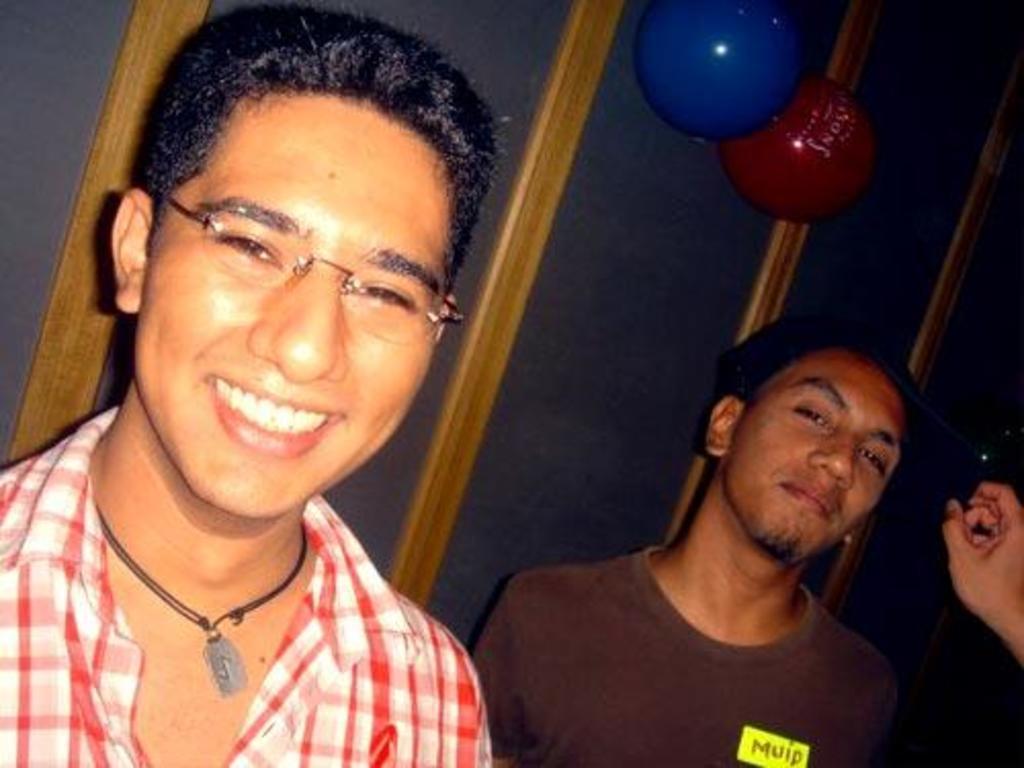Describe this image in one or two sentences. Here we can see two men. In the background there are two balloons on a platform. On the right at the bottom corner we can see a person hand holding a cap which is on another person. 